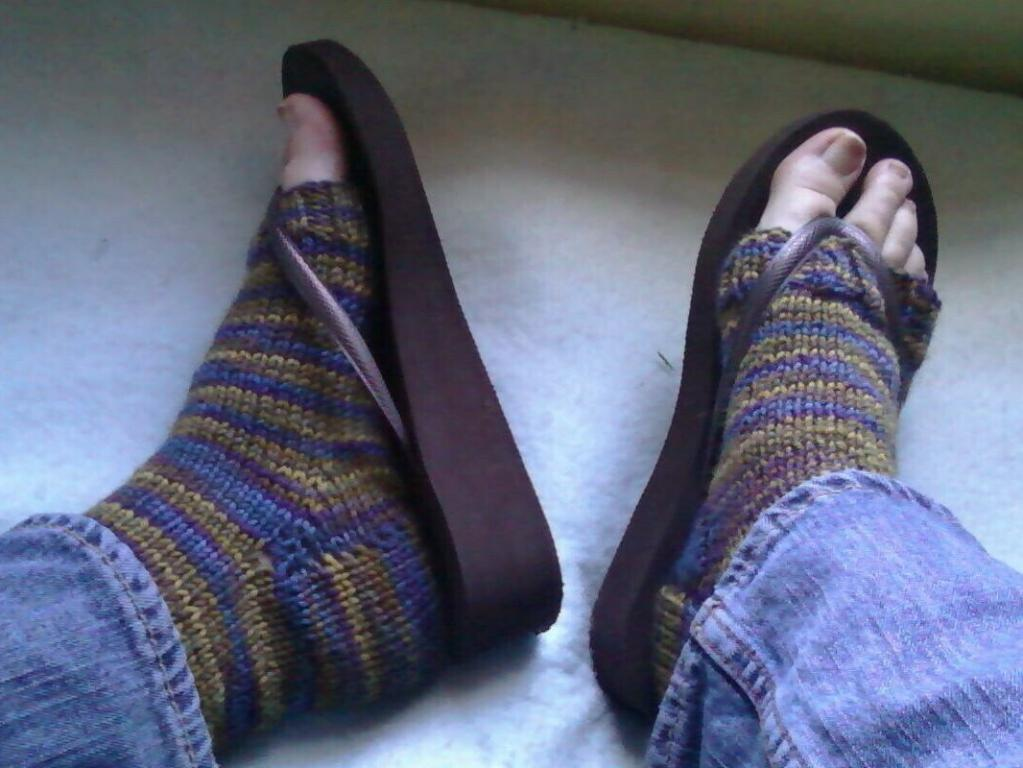Who or what is the main subject in the image? There is a person in the image. What part of the person's body can be seen in the image? The person's legs are visible in the image. What is the person wearing on their feet? The person is wearing footwear. How many stamps are on the person's legs in the image? There are no stamps visible on the person's legs in the image. 